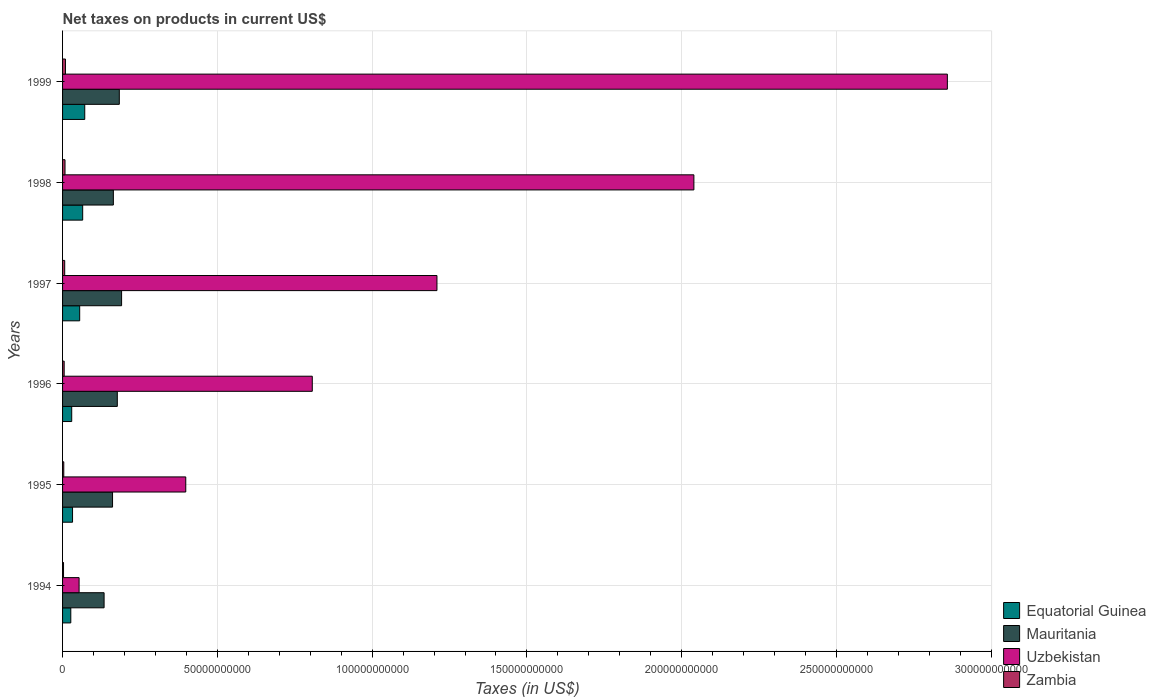How many different coloured bars are there?
Give a very brief answer. 4. Are the number of bars per tick equal to the number of legend labels?
Offer a terse response. Yes. Are the number of bars on each tick of the Y-axis equal?
Provide a short and direct response. Yes. How many bars are there on the 4th tick from the top?
Provide a short and direct response. 4. What is the label of the 2nd group of bars from the top?
Ensure brevity in your answer.  1998. In how many cases, is the number of bars for a given year not equal to the number of legend labels?
Provide a succinct answer. 0. What is the net taxes on products in Uzbekistan in 1996?
Provide a short and direct response. 8.07e+1. Across all years, what is the maximum net taxes on products in Equatorial Guinea?
Your answer should be compact. 7.16e+09. Across all years, what is the minimum net taxes on products in Mauritania?
Your response must be concise. 1.34e+1. In which year was the net taxes on products in Equatorial Guinea maximum?
Give a very brief answer. 1999. What is the total net taxes on products in Uzbekistan in the graph?
Give a very brief answer. 7.36e+11. What is the difference between the net taxes on products in Uzbekistan in 1996 and that in 1999?
Your answer should be very brief. -2.05e+11. What is the difference between the net taxes on products in Zambia in 1995 and the net taxes on products in Uzbekistan in 1999?
Your answer should be compact. -2.85e+11. What is the average net taxes on products in Uzbekistan per year?
Provide a short and direct response. 1.23e+11. In the year 1996, what is the difference between the net taxes on products in Uzbekistan and net taxes on products in Zambia?
Provide a short and direct response. 8.01e+1. What is the ratio of the net taxes on products in Equatorial Guinea in 1998 to that in 1999?
Your answer should be compact. 0.91. Is the net taxes on products in Uzbekistan in 1996 less than that in 1999?
Provide a short and direct response. Yes. Is the difference between the net taxes on products in Uzbekistan in 1994 and 1998 greater than the difference between the net taxes on products in Zambia in 1994 and 1998?
Offer a very short reply. No. What is the difference between the highest and the second highest net taxes on products in Equatorial Guinea?
Give a very brief answer. 6.64e+08. What is the difference between the highest and the lowest net taxes on products in Equatorial Guinea?
Make the answer very short. 4.50e+09. In how many years, is the net taxes on products in Uzbekistan greater than the average net taxes on products in Uzbekistan taken over all years?
Your answer should be very brief. 2. Is the sum of the net taxes on products in Equatorial Guinea in 1997 and 1999 greater than the maximum net taxes on products in Zambia across all years?
Keep it short and to the point. Yes. What does the 1st bar from the top in 1995 represents?
Provide a succinct answer. Zambia. What does the 2nd bar from the bottom in 1994 represents?
Provide a short and direct response. Mauritania. How many years are there in the graph?
Offer a very short reply. 6. Are the values on the major ticks of X-axis written in scientific E-notation?
Ensure brevity in your answer.  No. What is the title of the graph?
Give a very brief answer. Net taxes on products in current US$. Does "Hungary" appear as one of the legend labels in the graph?
Offer a very short reply. No. What is the label or title of the X-axis?
Provide a short and direct response. Taxes (in US$). What is the Taxes (in US$) of Equatorial Guinea in 1994?
Your answer should be compact. 2.66e+09. What is the Taxes (in US$) of Mauritania in 1994?
Ensure brevity in your answer.  1.34e+1. What is the Taxes (in US$) in Uzbekistan in 1994?
Provide a short and direct response. 5.34e+09. What is the Taxes (in US$) of Zambia in 1994?
Keep it short and to the point. 3.13e+08. What is the Taxes (in US$) in Equatorial Guinea in 1995?
Your response must be concise. 3.22e+09. What is the Taxes (in US$) in Mauritania in 1995?
Provide a succinct answer. 1.61e+1. What is the Taxes (in US$) of Uzbekistan in 1995?
Ensure brevity in your answer.  3.98e+1. What is the Taxes (in US$) in Zambia in 1995?
Offer a terse response. 3.93e+08. What is the Taxes (in US$) in Equatorial Guinea in 1996?
Offer a very short reply. 2.96e+09. What is the Taxes (in US$) in Mauritania in 1996?
Your answer should be very brief. 1.77e+1. What is the Taxes (in US$) in Uzbekistan in 1996?
Ensure brevity in your answer.  8.07e+1. What is the Taxes (in US$) of Zambia in 1996?
Provide a short and direct response. 5.20e+08. What is the Taxes (in US$) in Equatorial Guinea in 1997?
Ensure brevity in your answer.  5.53e+09. What is the Taxes (in US$) in Mauritania in 1997?
Offer a very short reply. 1.91e+1. What is the Taxes (in US$) in Uzbekistan in 1997?
Your answer should be compact. 1.21e+11. What is the Taxes (in US$) of Zambia in 1997?
Give a very brief answer. 6.88e+08. What is the Taxes (in US$) of Equatorial Guinea in 1998?
Offer a terse response. 6.50e+09. What is the Taxes (in US$) of Mauritania in 1998?
Keep it short and to the point. 1.64e+1. What is the Taxes (in US$) of Uzbekistan in 1998?
Your response must be concise. 2.04e+11. What is the Taxes (in US$) of Zambia in 1998?
Your response must be concise. 7.91e+08. What is the Taxes (in US$) of Equatorial Guinea in 1999?
Provide a succinct answer. 7.16e+09. What is the Taxes (in US$) in Mauritania in 1999?
Your answer should be very brief. 1.83e+1. What is the Taxes (in US$) in Uzbekistan in 1999?
Your answer should be very brief. 2.86e+11. What is the Taxes (in US$) of Zambia in 1999?
Ensure brevity in your answer.  9.34e+08. Across all years, what is the maximum Taxes (in US$) in Equatorial Guinea?
Make the answer very short. 7.16e+09. Across all years, what is the maximum Taxes (in US$) in Mauritania?
Provide a short and direct response. 1.91e+1. Across all years, what is the maximum Taxes (in US$) in Uzbekistan?
Give a very brief answer. 2.86e+11. Across all years, what is the maximum Taxes (in US$) in Zambia?
Your answer should be compact. 9.34e+08. Across all years, what is the minimum Taxes (in US$) in Equatorial Guinea?
Offer a terse response. 2.66e+09. Across all years, what is the minimum Taxes (in US$) of Mauritania?
Ensure brevity in your answer.  1.34e+1. Across all years, what is the minimum Taxes (in US$) in Uzbekistan?
Make the answer very short. 5.34e+09. Across all years, what is the minimum Taxes (in US$) of Zambia?
Give a very brief answer. 3.13e+08. What is the total Taxes (in US$) of Equatorial Guinea in the graph?
Your answer should be very brief. 2.80e+1. What is the total Taxes (in US$) of Mauritania in the graph?
Give a very brief answer. 1.01e+11. What is the total Taxes (in US$) of Uzbekistan in the graph?
Offer a terse response. 7.36e+11. What is the total Taxes (in US$) of Zambia in the graph?
Your answer should be very brief. 3.64e+09. What is the difference between the Taxes (in US$) of Equatorial Guinea in 1994 and that in 1995?
Provide a short and direct response. -5.62e+08. What is the difference between the Taxes (in US$) in Mauritania in 1994 and that in 1995?
Provide a short and direct response. -2.73e+09. What is the difference between the Taxes (in US$) of Uzbekistan in 1994 and that in 1995?
Your response must be concise. -3.45e+1. What is the difference between the Taxes (in US$) in Zambia in 1994 and that in 1995?
Your answer should be compact. -7.96e+07. What is the difference between the Taxes (in US$) of Equatorial Guinea in 1994 and that in 1996?
Make the answer very short. -2.95e+08. What is the difference between the Taxes (in US$) in Mauritania in 1994 and that in 1996?
Make the answer very short. -4.27e+09. What is the difference between the Taxes (in US$) of Uzbekistan in 1994 and that in 1996?
Keep it short and to the point. -7.53e+1. What is the difference between the Taxes (in US$) of Zambia in 1994 and that in 1996?
Provide a short and direct response. -2.06e+08. What is the difference between the Taxes (in US$) of Equatorial Guinea in 1994 and that in 1997?
Your answer should be compact. -2.87e+09. What is the difference between the Taxes (in US$) in Mauritania in 1994 and that in 1997?
Offer a very short reply. -5.65e+09. What is the difference between the Taxes (in US$) of Uzbekistan in 1994 and that in 1997?
Offer a very short reply. -1.16e+11. What is the difference between the Taxes (in US$) of Zambia in 1994 and that in 1997?
Your answer should be compact. -3.75e+08. What is the difference between the Taxes (in US$) in Equatorial Guinea in 1994 and that in 1998?
Provide a succinct answer. -3.84e+09. What is the difference between the Taxes (in US$) in Mauritania in 1994 and that in 1998?
Give a very brief answer. -2.99e+09. What is the difference between the Taxes (in US$) of Uzbekistan in 1994 and that in 1998?
Keep it short and to the point. -1.99e+11. What is the difference between the Taxes (in US$) in Zambia in 1994 and that in 1998?
Your answer should be very brief. -4.78e+08. What is the difference between the Taxes (in US$) of Equatorial Guinea in 1994 and that in 1999?
Your answer should be compact. -4.50e+09. What is the difference between the Taxes (in US$) in Mauritania in 1994 and that in 1999?
Your answer should be compact. -4.92e+09. What is the difference between the Taxes (in US$) of Uzbekistan in 1994 and that in 1999?
Ensure brevity in your answer.  -2.80e+11. What is the difference between the Taxes (in US$) in Zambia in 1994 and that in 1999?
Make the answer very short. -6.21e+08. What is the difference between the Taxes (in US$) in Equatorial Guinea in 1995 and that in 1996?
Your response must be concise. 2.67e+08. What is the difference between the Taxes (in US$) in Mauritania in 1995 and that in 1996?
Keep it short and to the point. -1.54e+09. What is the difference between the Taxes (in US$) of Uzbekistan in 1995 and that in 1996?
Provide a succinct answer. -4.09e+1. What is the difference between the Taxes (in US$) of Zambia in 1995 and that in 1996?
Keep it short and to the point. -1.27e+08. What is the difference between the Taxes (in US$) in Equatorial Guinea in 1995 and that in 1997?
Make the answer very short. -2.30e+09. What is the difference between the Taxes (in US$) of Mauritania in 1995 and that in 1997?
Your answer should be compact. -2.92e+09. What is the difference between the Taxes (in US$) in Uzbekistan in 1995 and that in 1997?
Offer a terse response. -8.11e+1. What is the difference between the Taxes (in US$) in Zambia in 1995 and that in 1997?
Provide a succinct answer. -2.95e+08. What is the difference between the Taxes (in US$) of Equatorial Guinea in 1995 and that in 1998?
Your answer should be compact. -3.28e+09. What is the difference between the Taxes (in US$) of Mauritania in 1995 and that in 1998?
Your answer should be compact. -2.59e+08. What is the difference between the Taxes (in US$) of Uzbekistan in 1995 and that in 1998?
Provide a succinct answer. -1.64e+11. What is the difference between the Taxes (in US$) in Zambia in 1995 and that in 1998?
Provide a succinct answer. -3.98e+08. What is the difference between the Taxes (in US$) of Equatorial Guinea in 1995 and that in 1999?
Provide a succinct answer. -3.94e+09. What is the difference between the Taxes (in US$) of Mauritania in 1995 and that in 1999?
Offer a terse response. -2.18e+09. What is the difference between the Taxes (in US$) in Uzbekistan in 1995 and that in 1999?
Offer a terse response. -2.46e+11. What is the difference between the Taxes (in US$) of Zambia in 1995 and that in 1999?
Your answer should be compact. -5.41e+08. What is the difference between the Taxes (in US$) of Equatorial Guinea in 1996 and that in 1997?
Provide a succinct answer. -2.57e+09. What is the difference between the Taxes (in US$) in Mauritania in 1996 and that in 1997?
Provide a succinct answer. -1.38e+09. What is the difference between the Taxes (in US$) of Uzbekistan in 1996 and that in 1997?
Your answer should be very brief. -4.03e+1. What is the difference between the Taxes (in US$) in Zambia in 1996 and that in 1997?
Offer a very short reply. -1.69e+08. What is the difference between the Taxes (in US$) in Equatorial Guinea in 1996 and that in 1998?
Your response must be concise. -3.54e+09. What is the difference between the Taxes (in US$) in Mauritania in 1996 and that in 1998?
Your answer should be very brief. 1.28e+09. What is the difference between the Taxes (in US$) in Uzbekistan in 1996 and that in 1998?
Provide a succinct answer. -1.23e+11. What is the difference between the Taxes (in US$) of Zambia in 1996 and that in 1998?
Keep it short and to the point. -2.72e+08. What is the difference between the Taxes (in US$) of Equatorial Guinea in 1996 and that in 1999?
Your answer should be very brief. -4.21e+09. What is the difference between the Taxes (in US$) of Mauritania in 1996 and that in 1999?
Make the answer very short. -6.46e+08. What is the difference between the Taxes (in US$) of Uzbekistan in 1996 and that in 1999?
Provide a succinct answer. -2.05e+11. What is the difference between the Taxes (in US$) of Zambia in 1996 and that in 1999?
Provide a short and direct response. -4.14e+08. What is the difference between the Taxes (in US$) in Equatorial Guinea in 1997 and that in 1998?
Provide a short and direct response. -9.73e+08. What is the difference between the Taxes (in US$) of Mauritania in 1997 and that in 1998?
Keep it short and to the point. 2.66e+09. What is the difference between the Taxes (in US$) in Uzbekistan in 1997 and that in 1998?
Offer a terse response. -8.30e+1. What is the difference between the Taxes (in US$) in Zambia in 1997 and that in 1998?
Make the answer very short. -1.03e+08. What is the difference between the Taxes (in US$) in Equatorial Guinea in 1997 and that in 1999?
Your answer should be very brief. -1.64e+09. What is the difference between the Taxes (in US$) in Mauritania in 1997 and that in 1999?
Make the answer very short. 7.37e+08. What is the difference between the Taxes (in US$) of Uzbekistan in 1997 and that in 1999?
Your answer should be very brief. -1.65e+11. What is the difference between the Taxes (in US$) of Zambia in 1997 and that in 1999?
Ensure brevity in your answer.  -2.46e+08. What is the difference between the Taxes (in US$) of Equatorial Guinea in 1998 and that in 1999?
Your answer should be very brief. -6.64e+08. What is the difference between the Taxes (in US$) of Mauritania in 1998 and that in 1999?
Offer a terse response. -1.92e+09. What is the difference between the Taxes (in US$) in Uzbekistan in 1998 and that in 1999?
Provide a short and direct response. -8.19e+1. What is the difference between the Taxes (in US$) of Zambia in 1998 and that in 1999?
Your response must be concise. -1.43e+08. What is the difference between the Taxes (in US$) in Equatorial Guinea in 1994 and the Taxes (in US$) in Mauritania in 1995?
Offer a very short reply. -1.35e+1. What is the difference between the Taxes (in US$) of Equatorial Guinea in 1994 and the Taxes (in US$) of Uzbekistan in 1995?
Ensure brevity in your answer.  -3.71e+1. What is the difference between the Taxes (in US$) of Equatorial Guinea in 1994 and the Taxes (in US$) of Zambia in 1995?
Your answer should be very brief. 2.27e+09. What is the difference between the Taxes (in US$) of Mauritania in 1994 and the Taxes (in US$) of Uzbekistan in 1995?
Provide a short and direct response. -2.64e+1. What is the difference between the Taxes (in US$) of Mauritania in 1994 and the Taxes (in US$) of Zambia in 1995?
Offer a terse response. 1.30e+1. What is the difference between the Taxes (in US$) of Uzbekistan in 1994 and the Taxes (in US$) of Zambia in 1995?
Keep it short and to the point. 4.95e+09. What is the difference between the Taxes (in US$) of Equatorial Guinea in 1994 and the Taxes (in US$) of Mauritania in 1996?
Offer a very short reply. -1.50e+1. What is the difference between the Taxes (in US$) of Equatorial Guinea in 1994 and the Taxes (in US$) of Uzbekistan in 1996?
Offer a terse response. -7.80e+1. What is the difference between the Taxes (in US$) of Equatorial Guinea in 1994 and the Taxes (in US$) of Zambia in 1996?
Provide a succinct answer. 2.14e+09. What is the difference between the Taxes (in US$) in Mauritania in 1994 and the Taxes (in US$) in Uzbekistan in 1996?
Make the answer very short. -6.72e+1. What is the difference between the Taxes (in US$) of Mauritania in 1994 and the Taxes (in US$) of Zambia in 1996?
Ensure brevity in your answer.  1.29e+1. What is the difference between the Taxes (in US$) in Uzbekistan in 1994 and the Taxes (in US$) in Zambia in 1996?
Offer a terse response. 4.82e+09. What is the difference between the Taxes (in US$) of Equatorial Guinea in 1994 and the Taxes (in US$) of Mauritania in 1997?
Your answer should be compact. -1.64e+1. What is the difference between the Taxes (in US$) of Equatorial Guinea in 1994 and the Taxes (in US$) of Uzbekistan in 1997?
Provide a succinct answer. -1.18e+11. What is the difference between the Taxes (in US$) in Equatorial Guinea in 1994 and the Taxes (in US$) in Zambia in 1997?
Keep it short and to the point. 1.97e+09. What is the difference between the Taxes (in US$) in Mauritania in 1994 and the Taxes (in US$) in Uzbekistan in 1997?
Offer a terse response. -1.08e+11. What is the difference between the Taxes (in US$) in Mauritania in 1994 and the Taxes (in US$) in Zambia in 1997?
Ensure brevity in your answer.  1.27e+1. What is the difference between the Taxes (in US$) of Uzbekistan in 1994 and the Taxes (in US$) of Zambia in 1997?
Offer a very short reply. 4.65e+09. What is the difference between the Taxes (in US$) in Equatorial Guinea in 1994 and the Taxes (in US$) in Mauritania in 1998?
Make the answer very short. -1.37e+1. What is the difference between the Taxes (in US$) of Equatorial Guinea in 1994 and the Taxes (in US$) of Uzbekistan in 1998?
Offer a terse response. -2.01e+11. What is the difference between the Taxes (in US$) of Equatorial Guinea in 1994 and the Taxes (in US$) of Zambia in 1998?
Offer a terse response. 1.87e+09. What is the difference between the Taxes (in US$) of Mauritania in 1994 and the Taxes (in US$) of Uzbekistan in 1998?
Make the answer very short. -1.91e+11. What is the difference between the Taxes (in US$) of Mauritania in 1994 and the Taxes (in US$) of Zambia in 1998?
Provide a short and direct response. 1.26e+1. What is the difference between the Taxes (in US$) in Uzbekistan in 1994 and the Taxes (in US$) in Zambia in 1998?
Provide a succinct answer. 4.55e+09. What is the difference between the Taxes (in US$) in Equatorial Guinea in 1994 and the Taxes (in US$) in Mauritania in 1999?
Provide a succinct answer. -1.57e+1. What is the difference between the Taxes (in US$) in Equatorial Guinea in 1994 and the Taxes (in US$) in Uzbekistan in 1999?
Give a very brief answer. -2.83e+11. What is the difference between the Taxes (in US$) of Equatorial Guinea in 1994 and the Taxes (in US$) of Zambia in 1999?
Provide a succinct answer. 1.73e+09. What is the difference between the Taxes (in US$) of Mauritania in 1994 and the Taxes (in US$) of Uzbekistan in 1999?
Your answer should be compact. -2.72e+11. What is the difference between the Taxes (in US$) of Mauritania in 1994 and the Taxes (in US$) of Zambia in 1999?
Offer a very short reply. 1.25e+1. What is the difference between the Taxes (in US$) of Uzbekistan in 1994 and the Taxes (in US$) of Zambia in 1999?
Make the answer very short. 4.41e+09. What is the difference between the Taxes (in US$) of Equatorial Guinea in 1995 and the Taxes (in US$) of Mauritania in 1996?
Provide a succinct answer. -1.45e+1. What is the difference between the Taxes (in US$) of Equatorial Guinea in 1995 and the Taxes (in US$) of Uzbekistan in 1996?
Provide a succinct answer. -7.74e+1. What is the difference between the Taxes (in US$) in Equatorial Guinea in 1995 and the Taxes (in US$) in Zambia in 1996?
Provide a succinct answer. 2.70e+09. What is the difference between the Taxes (in US$) of Mauritania in 1995 and the Taxes (in US$) of Uzbekistan in 1996?
Your answer should be very brief. -6.45e+1. What is the difference between the Taxes (in US$) in Mauritania in 1995 and the Taxes (in US$) in Zambia in 1996?
Provide a succinct answer. 1.56e+1. What is the difference between the Taxes (in US$) in Uzbekistan in 1995 and the Taxes (in US$) in Zambia in 1996?
Give a very brief answer. 3.93e+1. What is the difference between the Taxes (in US$) in Equatorial Guinea in 1995 and the Taxes (in US$) in Mauritania in 1997?
Offer a very short reply. -1.58e+1. What is the difference between the Taxes (in US$) of Equatorial Guinea in 1995 and the Taxes (in US$) of Uzbekistan in 1997?
Your answer should be compact. -1.18e+11. What is the difference between the Taxes (in US$) of Equatorial Guinea in 1995 and the Taxes (in US$) of Zambia in 1997?
Your response must be concise. 2.53e+09. What is the difference between the Taxes (in US$) in Mauritania in 1995 and the Taxes (in US$) in Uzbekistan in 1997?
Your response must be concise. -1.05e+11. What is the difference between the Taxes (in US$) in Mauritania in 1995 and the Taxes (in US$) in Zambia in 1997?
Your answer should be compact. 1.55e+1. What is the difference between the Taxes (in US$) of Uzbekistan in 1995 and the Taxes (in US$) of Zambia in 1997?
Make the answer very short. 3.91e+1. What is the difference between the Taxes (in US$) in Equatorial Guinea in 1995 and the Taxes (in US$) in Mauritania in 1998?
Keep it short and to the point. -1.32e+1. What is the difference between the Taxes (in US$) of Equatorial Guinea in 1995 and the Taxes (in US$) of Uzbekistan in 1998?
Offer a very short reply. -2.01e+11. What is the difference between the Taxes (in US$) in Equatorial Guinea in 1995 and the Taxes (in US$) in Zambia in 1998?
Provide a succinct answer. 2.43e+09. What is the difference between the Taxes (in US$) of Mauritania in 1995 and the Taxes (in US$) of Uzbekistan in 1998?
Offer a very short reply. -1.88e+11. What is the difference between the Taxes (in US$) in Mauritania in 1995 and the Taxes (in US$) in Zambia in 1998?
Ensure brevity in your answer.  1.54e+1. What is the difference between the Taxes (in US$) in Uzbekistan in 1995 and the Taxes (in US$) in Zambia in 1998?
Keep it short and to the point. 3.90e+1. What is the difference between the Taxes (in US$) in Equatorial Guinea in 1995 and the Taxes (in US$) in Mauritania in 1999?
Offer a terse response. -1.51e+1. What is the difference between the Taxes (in US$) of Equatorial Guinea in 1995 and the Taxes (in US$) of Uzbekistan in 1999?
Ensure brevity in your answer.  -2.83e+11. What is the difference between the Taxes (in US$) in Equatorial Guinea in 1995 and the Taxes (in US$) in Zambia in 1999?
Your response must be concise. 2.29e+09. What is the difference between the Taxes (in US$) in Mauritania in 1995 and the Taxes (in US$) in Uzbekistan in 1999?
Keep it short and to the point. -2.70e+11. What is the difference between the Taxes (in US$) in Mauritania in 1995 and the Taxes (in US$) in Zambia in 1999?
Your answer should be very brief. 1.52e+1. What is the difference between the Taxes (in US$) of Uzbekistan in 1995 and the Taxes (in US$) of Zambia in 1999?
Provide a short and direct response. 3.89e+1. What is the difference between the Taxes (in US$) in Equatorial Guinea in 1996 and the Taxes (in US$) in Mauritania in 1997?
Make the answer very short. -1.61e+1. What is the difference between the Taxes (in US$) of Equatorial Guinea in 1996 and the Taxes (in US$) of Uzbekistan in 1997?
Keep it short and to the point. -1.18e+11. What is the difference between the Taxes (in US$) in Equatorial Guinea in 1996 and the Taxes (in US$) in Zambia in 1997?
Ensure brevity in your answer.  2.27e+09. What is the difference between the Taxes (in US$) of Mauritania in 1996 and the Taxes (in US$) of Uzbekistan in 1997?
Provide a succinct answer. -1.03e+11. What is the difference between the Taxes (in US$) of Mauritania in 1996 and the Taxes (in US$) of Zambia in 1997?
Make the answer very short. 1.70e+1. What is the difference between the Taxes (in US$) of Uzbekistan in 1996 and the Taxes (in US$) of Zambia in 1997?
Offer a terse response. 8.00e+1. What is the difference between the Taxes (in US$) of Equatorial Guinea in 1996 and the Taxes (in US$) of Mauritania in 1998?
Ensure brevity in your answer.  -1.34e+1. What is the difference between the Taxes (in US$) in Equatorial Guinea in 1996 and the Taxes (in US$) in Uzbekistan in 1998?
Make the answer very short. -2.01e+11. What is the difference between the Taxes (in US$) in Equatorial Guinea in 1996 and the Taxes (in US$) in Zambia in 1998?
Give a very brief answer. 2.16e+09. What is the difference between the Taxes (in US$) of Mauritania in 1996 and the Taxes (in US$) of Uzbekistan in 1998?
Give a very brief answer. -1.86e+11. What is the difference between the Taxes (in US$) in Mauritania in 1996 and the Taxes (in US$) in Zambia in 1998?
Ensure brevity in your answer.  1.69e+1. What is the difference between the Taxes (in US$) in Uzbekistan in 1996 and the Taxes (in US$) in Zambia in 1998?
Offer a terse response. 7.99e+1. What is the difference between the Taxes (in US$) of Equatorial Guinea in 1996 and the Taxes (in US$) of Mauritania in 1999?
Offer a very short reply. -1.54e+1. What is the difference between the Taxes (in US$) of Equatorial Guinea in 1996 and the Taxes (in US$) of Uzbekistan in 1999?
Provide a short and direct response. -2.83e+11. What is the difference between the Taxes (in US$) of Equatorial Guinea in 1996 and the Taxes (in US$) of Zambia in 1999?
Your response must be concise. 2.02e+09. What is the difference between the Taxes (in US$) in Mauritania in 1996 and the Taxes (in US$) in Uzbekistan in 1999?
Keep it short and to the point. -2.68e+11. What is the difference between the Taxes (in US$) in Mauritania in 1996 and the Taxes (in US$) in Zambia in 1999?
Provide a short and direct response. 1.67e+1. What is the difference between the Taxes (in US$) in Uzbekistan in 1996 and the Taxes (in US$) in Zambia in 1999?
Your answer should be very brief. 7.97e+1. What is the difference between the Taxes (in US$) in Equatorial Guinea in 1997 and the Taxes (in US$) in Mauritania in 1998?
Your answer should be very brief. -1.09e+1. What is the difference between the Taxes (in US$) of Equatorial Guinea in 1997 and the Taxes (in US$) of Uzbekistan in 1998?
Provide a short and direct response. -1.98e+11. What is the difference between the Taxes (in US$) of Equatorial Guinea in 1997 and the Taxes (in US$) of Zambia in 1998?
Your answer should be very brief. 4.74e+09. What is the difference between the Taxes (in US$) of Mauritania in 1997 and the Taxes (in US$) of Uzbekistan in 1998?
Give a very brief answer. -1.85e+11. What is the difference between the Taxes (in US$) in Mauritania in 1997 and the Taxes (in US$) in Zambia in 1998?
Your answer should be compact. 1.83e+1. What is the difference between the Taxes (in US$) in Uzbekistan in 1997 and the Taxes (in US$) in Zambia in 1998?
Give a very brief answer. 1.20e+11. What is the difference between the Taxes (in US$) of Equatorial Guinea in 1997 and the Taxes (in US$) of Mauritania in 1999?
Provide a succinct answer. -1.28e+1. What is the difference between the Taxes (in US$) of Equatorial Guinea in 1997 and the Taxes (in US$) of Uzbekistan in 1999?
Your answer should be compact. -2.80e+11. What is the difference between the Taxes (in US$) of Equatorial Guinea in 1997 and the Taxes (in US$) of Zambia in 1999?
Offer a terse response. 4.59e+09. What is the difference between the Taxes (in US$) of Mauritania in 1997 and the Taxes (in US$) of Uzbekistan in 1999?
Ensure brevity in your answer.  -2.67e+11. What is the difference between the Taxes (in US$) in Mauritania in 1997 and the Taxes (in US$) in Zambia in 1999?
Your answer should be compact. 1.81e+1. What is the difference between the Taxes (in US$) in Uzbekistan in 1997 and the Taxes (in US$) in Zambia in 1999?
Keep it short and to the point. 1.20e+11. What is the difference between the Taxes (in US$) in Equatorial Guinea in 1998 and the Taxes (in US$) in Mauritania in 1999?
Make the answer very short. -1.18e+1. What is the difference between the Taxes (in US$) of Equatorial Guinea in 1998 and the Taxes (in US$) of Uzbekistan in 1999?
Provide a succinct answer. -2.79e+11. What is the difference between the Taxes (in US$) in Equatorial Guinea in 1998 and the Taxes (in US$) in Zambia in 1999?
Give a very brief answer. 5.57e+09. What is the difference between the Taxes (in US$) of Mauritania in 1998 and the Taxes (in US$) of Uzbekistan in 1999?
Make the answer very short. -2.69e+11. What is the difference between the Taxes (in US$) in Mauritania in 1998 and the Taxes (in US$) in Zambia in 1999?
Make the answer very short. 1.55e+1. What is the difference between the Taxes (in US$) in Uzbekistan in 1998 and the Taxes (in US$) in Zambia in 1999?
Your answer should be very brief. 2.03e+11. What is the average Taxes (in US$) in Equatorial Guinea per year?
Your response must be concise. 4.67e+09. What is the average Taxes (in US$) of Mauritania per year?
Your answer should be compact. 1.68e+1. What is the average Taxes (in US$) in Uzbekistan per year?
Ensure brevity in your answer.  1.23e+11. What is the average Taxes (in US$) of Zambia per year?
Your response must be concise. 6.06e+08. In the year 1994, what is the difference between the Taxes (in US$) in Equatorial Guinea and Taxes (in US$) in Mauritania?
Provide a succinct answer. -1.08e+1. In the year 1994, what is the difference between the Taxes (in US$) in Equatorial Guinea and Taxes (in US$) in Uzbekistan?
Make the answer very short. -2.68e+09. In the year 1994, what is the difference between the Taxes (in US$) of Equatorial Guinea and Taxes (in US$) of Zambia?
Ensure brevity in your answer.  2.35e+09. In the year 1994, what is the difference between the Taxes (in US$) of Mauritania and Taxes (in US$) of Uzbekistan?
Your response must be concise. 8.07e+09. In the year 1994, what is the difference between the Taxes (in US$) in Mauritania and Taxes (in US$) in Zambia?
Offer a terse response. 1.31e+1. In the year 1994, what is the difference between the Taxes (in US$) in Uzbekistan and Taxes (in US$) in Zambia?
Your answer should be compact. 5.03e+09. In the year 1995, what is the difference between the Taxes (in US$) of Equatorial Guinea and Taxes (in US$) of Mauritania?
Keep it short and to the point. -1.29e+1. In the year 1995, what is the difference between the Taxes (in US$) of Equatorial Guinea and Taxes (in US$) of Uzbekistan?
Give a very brief answer. -3.66e+1. In the year 1995, what is the difference between the Taxes (in US$) in Equatorial Guinea and Taxes (in US$) in Zambia?
Your response must be concise. 2.83e+09. In the year 1995, what is the difference between the Taxes (in US$) in Mauritania and Taxes (in US$) in Uzbekistan?
Offer a terse response. -2.37e+1. In the year 1995, what is the difference between the Taxes (in US$) of Mauritania and Taxes (in US$) of Zambia?
Your answer should be very brief. 1.58e+1. In the year 1995, what is the difference between the Taxes (in US$) in Uzbekistan and Taxes (in US$) in Zambia?
Give a very brief answer. 3.94e+1. In the year 1996, what is the difference between the Taxes (in US$) of Equatorial Guinea and Taxes (in US$) of Mauritania?
Keep it short and to the point. -1.47e+1. In the year 1996, what is the difference between the Taxes (in US$) of Equatorial Guinea and Taxes (in US$) of Uzbekistan?
Your answer should be very brief. -7.77e+1. In the year 1996, what is the difference between the Taxes (in US$) of Equatorial Guinea and Taxes (in US$) of Zambia?
Give a very brief answer. 2.44e+09. In the year 1996, what is the difference between the Taxes (in US$) of Mauritania and Taxes (in US$) of Uzbekistan?
Offer a very short reply. -6.30e+1. In the year 1996, what is the difference between the Taxes (in US$) of Mauritania and Taxes (in US$) of Zambia?
Make the answer very short. 1.72e+1. In the year 1996, what is the difference between the Taxes (in US$) in Uzbekistan and Taxes (in US$) in Zambia?
Your answer should be compact. 8.01e+1. In the year 1997, what is the difference between the Taxes (in US$) in Equatorial Guinea and Taxes (in US$) in Mauritania?
Provide a short and direct response. -1.35e+1. In the year 1997, what is the difference between the Taxes (in US$) of Equatorial Guinea and Taxes (in US$) of Uzbekistan?
Your response must be concise. -1.15e+11. In the year 1997, what is the difference between the Taxes (in US$) in Equatorial Guinea and Taxes (in US$) in Zambia?
Make the answer very short. 4.84e+09. In the year 1997, what is the difference between the Taxes (in US$) in Mauritania and Taxes (in US$) in Uzbekistan?
Provide a short and direct response. -1.02e+11. In the year 1997, what is the difference between the Taxes (in US$) of Mauritania and Taxes (in US$) of Zambia?
Make the answer very short. 1.84e+1. In the year 1997, what is the difference between the Taxes (in US$) of Uzbekistan and Taxes (in US$) of Zambia?
Provide a short and direct response. 1.20e+11. In the year 1998, what is the difference between the Taxes (in US$) of Equatorial Guinea and Taxes (in US$) of Mauritania?
Ensure brevity in your answer.  -9.90e+09. In the year 1998, what is the difference between the Taxes (in US$) in Equatorial Guinea and Taxes (in US$) in Uzbekistan?
Your answer should be compact. -1.97e+11. In the year 1998, what is the difference between the Taxes (in US$) in Equatorial Guinea and Taxes (in US$) in Zambia?
Your response must be concise. 5.71e+09. In the year 1998, what is the difference between the Taxes (in US$) of Mauritania and Taxes (in US$) of Uzbekistan?
Keep it short and to the point. -1.88e+11. In the year 1998, what is the difference between the Taxes (in US$) of Mauritania and Taxes (in US$) of Zambia?
Keep it short and to the point. 1.56e+1. In the year 1998, what is the difference between the Taxes (in US$) of Uzbekistan and Taxes (in US$) of Zambia?
Give a very brief answer. 2.03e+11. In the year 1999, what is the difference between the Taxes (in US$) of Equatorial Guinea and Taxes (in US$) of Mauritania?
Make the answer very short. -1.12e+1. In the year 1999, what is the difference between the Taxes (in US$) in Equatorial Guinea and Taxes (in US$) in Uzbekistan?
Keep it short and to the point. -2.79e+11. In the year 1999, what is the difference between the Taxes (in US$) in Equatorial Guinea and Taxes (in US$) in Zambia?
Your answer should be compact. 6.23e+09. In the year 1999, what is the difference between the Taxes (in US$) of Mauritania and Taxes (in US$) of Uzbekistan?
Your response must be concise. -2.67e+11. In the year 1999, what is the difference between the Taxes (in US$) of Mauritania and Taxes (in US$) of Zambia?
Ensure brevity in your answer.  1.74e+1. In the year 1999, what is the difference between the Taxes (in US$) of Uzbekistan and Taxes (in US$) of Zambia?
Provide a short and direct response. 2.85e+11. What is the ratio of the Taxes (in US$) of Equatorial Guinea in 1994 to that in 1995?
Your answer should be compact. 0.83. What is the ratio of the Taxes (in US$) of Mauritania in 1994 to that in 1995?
Your answer should be very brief. 0.83. What is the ratio of the Taxes (in US$) in Uzbekistan in 1994 to that in 1995?
Your answer should be very brief. 0.13. What is the ratio of the Taxes (in US$) in Zambia in 1994 to that in 1995?
Ensure brevity in your answer.  0.8. What is the ratio of the Taxes (in US$) in Equatorial Guinea in 1994 to that in 1996?
Provide a short and direct response. 0.9. What is the ratio of the Taxes (in US$) of Mauritania in 1994 to that in 1996?
Your response must be concise. 0.76. What is the ratio of the Taxes (in US$) of Uzbekistan in 1994 to that in 1996?
Ensure brevity in your answer.  0.07. What is the ratio of the Taxes (in US$) of Zambia in 1994 to that in 1996?
Ensure brevity in your answer.  0.6. What is the ratio of the Taxes (in US$) of Equatorial Guinea in 1994 to that in 1997?
Ensure brevity in your answer.  0.48. What is the ratio of the Taxes (in US$) of Mauritania in 1994 to that in 1997?
Give a very brief answer. 0.7. What is the ratio of the Taxes (in US$) of Uzbekistan in 1994 to that in 1997?
Ensure brevity in your answer.  0.04. What is the ratio of the Taxes (in US$) of Zambia in 1994 to that in 1997?
Give a very brief answer. 0.46. What is the ratio of the Taxes (in US$) of Equatorial Guinea in 1994 to that in 1998?
Make the answer very short. 0.41. What is the ratio of the Taxes (in US$) in Mauritania in 1994 to that in 1998?
Provide a short and direct response. 0.82. What is the ratio of the Taxes (in US$) of Uzbekistan in 1994 to that in 1998?
Your response must be concise. 0.03. What is the ratio of the Taxes (in US$) in Zambia in 1994 to that in 1998?
Keep it short and to the point. 0.4. What is the ratio of the Taxes (in US$) of Equatorial Guinea in 1994 to that in 1999?
Ensure brevity in your answer.  0.37. What is the ratio of the Taxes (in US$) in Mauritania in 1994 to that in 1999?
Ensure brevity in your answer.  0.73. What is the ratio of the Taxes (in US$) in Uzbekistan in 1994 to that in 1999?
Ensure brevity in your answer.  0.02. What is the ratio of the Taxes (in US$) of Zambia in 1994 to that in 1999?
Make the answer very short. 0.34. What is the ratio of the Taxes (in US$) of Equatorial Guinea in 1995 to that in 1996?
Your answer should be very brief. 1.09. What is the ratio of the Taxes (in US$) of Mauritania in 1995 to that in 1996?
Provide a short and direct response. 0.91. What is the ratio of the Taxes (in US$) in Uzbekistan in 1995 to that in 1996?
Make the answer very short. 0.49. What is the ratio of the Taxes (in US$) of Zambia in 1995 to that in 1996?
Offer a very short reply. 0.76. What is the ratio of the Taxes (in US$) of Equatorial Guinea in 1995 to that in 1997?
Provide a succinct answer. 0.58. What is the ratio of the Taxes (in US$) of Mauritania in 1995 to that in 1997?
Make the answer very short. 0.85. What is the ratio of the Taxes (in US$) in Uzbekistan in 1995 to that in 1997?
Provide a short and direct response. 0.33. What is the ratio of the Taxes (in US$) of Zambia in 1995 to that in 1997?
Offer a very short reply. 0.57. What is the ratio of the Taxes (in US$) of Equatorial Guinea in 1995 to that in 1998?
Your response must be concise. 0.5. What is the ratio of the Taxes (in US$) of Mauritania in 1995 to that in 1998?
Your response must be concise. 0.98. What is the ratio of the Taxes (in US$) of Uzbekistan in 1995 to that in 1998?
Keep it short and to the point. 0.2. What is the ratio of the Taxes (in US$) of Zambia in 1995 to that in 1998?
Your answer should be very brief. 0.5. What is the ratio of the Taxes (in US$) in Equatorial Guinea in 1995 to that in 1999?
Keep it short and to the point. 0.45. What is the ratio of the Taxes (in US$) of Mauritania in 1995 to that in 1999?
Keep it short and to the point. 0.88. What is the ratio of the Taxes (in US$) in Uzbekistan in 1995 to that in 1999?
Your response must be concise. 0.14. What is the ratio of the Taxes (in US$) in Zambia in 1995 to that in 1999?
Give a very brief answer. 0.42. What is the ratio of the Taxes (in US$) in Equatorial Guinea in 1996 to that in 1997?
Provide a succinct answer. 0.53. What is the ratio of the Taxes (in US$) of Mauritania in 1996 to that in 1997?
Your response must be concise. 0.93. What is the ratio of the Taxes (in US$) in Uzbekistan in 1996 to that in 1997?
Provide a succinct answer. 0.67. What is the ratio of the Taxes (in US$) of Zambia in 1996 to that in 1997?
Give a very brief answer. 0.76. What is the ratio of the Taxes (in US$) of Equatorial Guinea in 1996 to that in 1998?
Your answer should be very brief. 0.45. What is the ratio of the Taxes (in US$) of Mauritania in 1996 to that in 1998?
Your answer should be compact. 1.08. What is the ratio of the Taxes (in US$) in Uzbekistan in 1996 to that in 1998?
Your answer should be compact. 0.4. What is the ratio of the Taxes (in US$) of Zambia in 1996 to that in 1998?
Your answer should be very brief. 0.66. What is the ratio of the Taxes (in US$) in Equatorial Guinea in 1996 to that in 1999?
Provide a succinct answer. 0.41. What is the ratio of the Taxes (in US$) in Mauritania in 1996 to that in 1999?
Offer a terse response. 0.96. What is the ratio of the Taxes (in US$) of Uzbekistan in 1996 to that in 1999?
Offer a very short reply. 0.28. What is the ratio of the Taxes (in US$) in Zambia in 1996 to that in 1999?
Keep it short and to the point. 0.56. What is the ratio of the Taxes (in US$) of Equatorial Guinea in 1997 to that in 1998?
Give a very brief answer. 0.85. What is the ratio of the Taxes (in US$) in Mauritania in 1997 to that in 1998?
Ensure brevity in your answer.  1.16. What is the ratio of the Taxes (in US$) in Uzbekistan in 1997 to that in 1998?
Provide a succinct answer. 0.59. What is the ratio of the Taxes (in US$) in Zambia in 1997 to that in 1998?
Ensure brevity in your answer.  0.87. What is the ratio of the Taxes (in US$) of Equatorial Guinea in 1997 to that in 1999?
Offer a terse response. 0.77. What is the ratio of the Taxes (in US$) in Mauritania in 1997 to that in 1999?
Your response must be concise. 1.04. What is the ratio of the Taxes (in US$) of Uzbekistan in 1997 to that in 1999?
Offer a terse response. 0.42. What is the ratio of the Taxes (in US$) in Zambia in 1997 to that in 1999?
Provide a short and direct response. 0.74. What is the ratio of the Taxes (in US$) of Equatorial Guinea in 1998 to that in 1999?
Offer a terse response. 0.91. What is the ratio of the Taxes (in US$) in Mauritania in 1998 to that in 1999?
Give a very brief answer. 0.9. What is the ratio of the Taxes (in US$) in Uzbekistan in 1998 to that in 1999?
Keep it short and to the point. 0.71. What is the ratio of the Taxes (in US$) of Zambia in 1998 to that in 1999?
Provide a short and direct response. 0.85. What is the difference between the highest and the second highest Taxes (in US$) in Equatorial Guinea?
Ensure brevity in your answer.  6.64e+08. What is the difference between the highest and the second highest Taxes (in US$) of Mauritania?
Offer a terse response. 7.37e+08. What is the difference between the highest and the second highest Taxes (in US$) in Uzbekistan?
Make the answer very short. 8.19e+1. What is the difference between the highest and the second highest Taxes (in US$) of Zambia?
Make the answer very short. 1.43e+08. What is the difference between the highest and the lowest Taxes (in US$) of Equatorial Guinea?
Offer a terse response. 4.50e+09. What is the difference between the highest and the lowest Taxes (in US$) of Mauritania?
Provide a short and direct response. 5.65e+09. What is the difference between the highest and the lowest Taxes (in US$) in Uzbekistan?
Ensure brevity in your answer.  2.80e+11. What is the difference between the highest and the lowest Taxes (in US$) of Zambia?
Your answer should be very brief. 6.21e+08. 